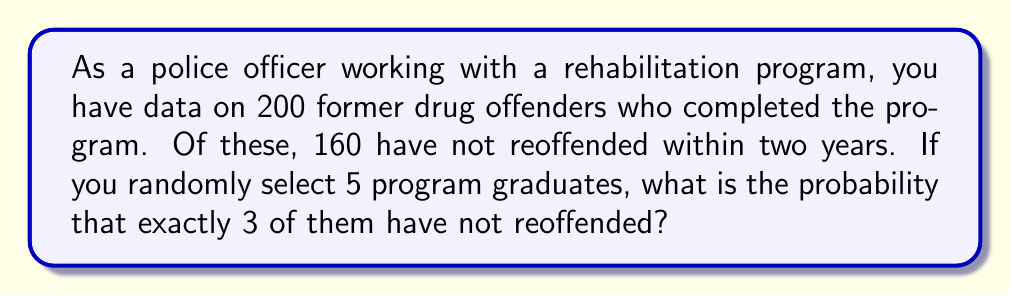Teach me how to tackle this problem. To solve this problem, we'll use the binomial probability formula, as we're dealing with a fixed number of independent trials (selecting 5 graduates) with two possible outcomes for each (reoffended or not reoffended).

Let's define our variables:
$n = 5$ (number of graduates selected)
$k = 3$ (number of successes, i.e., not reoffended)
$p = 160/200 = 0.8$ (probability of success for each trial)

The binomial probability formula is:

$$ P(X = k) = \binom{n}{k} p^k (1-p)^{n-k} $$

Where $\binom{n}{k}$ is the binomial coefficient, calculated as:

$$ \binom{n}{k} = \frac{n!}{k!(n-k)!} $$

Let's calculate each part:

1) $\binom{5}{3} = \frac{5!}{3!(5-3)!} = \frac{5 \cdot 4}{2 \cdot 1} = 10$

2) $p^k = 0.8^3 = 0.512$

3) $(1-p)^{n-k} = 0.2^2 = 0.04$

Now, let's put it all together:

$$ P(X = 3) = 10 \cdot 0.512 \cdot 0.04 = 0.2048 $$

Therefore, the probability of exactly 3 out of 5 randomly selected program graduates not having reoffended is 0.2048 or 20.48%.
Answer: 0.2048 or 20.48% 